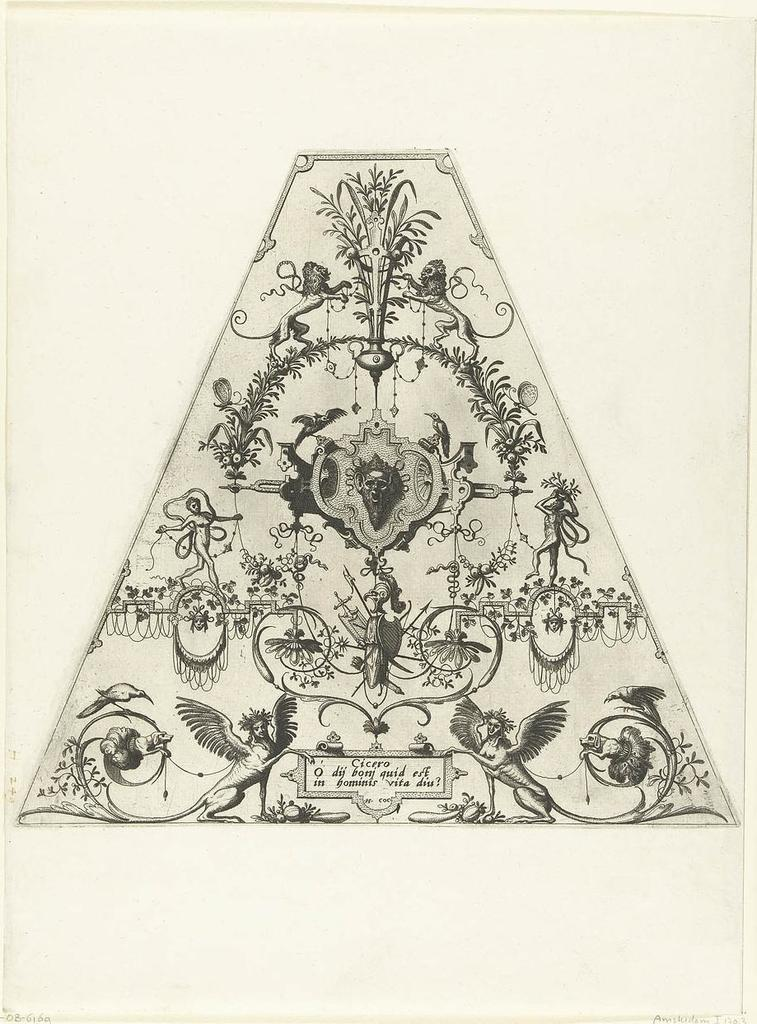What type of animal is depicted in the art? There is an animal depicted in the art, but the specific type cannot be determined from the provided facts. What other living creatures are depicted in the art? There are birds depicted in the art. What non-living object is depicted in the art? There is a plant depicted in the art. What type of human-made object is depicted in the art? There is a statue of a person's face depicted in the art. What type of text is present in the art? There is writing on the paper in the art. What type of amusement can be seen in the art? There is no amusement depicted in the art; it features an animal, birds, a plant, a statue of a person's face, and writing on the paper. What type of ornament is hanging from the statue's neck in the art? There is no ornament hanging from the statue's neck in the art; the statue is depicted with a person's face only. 